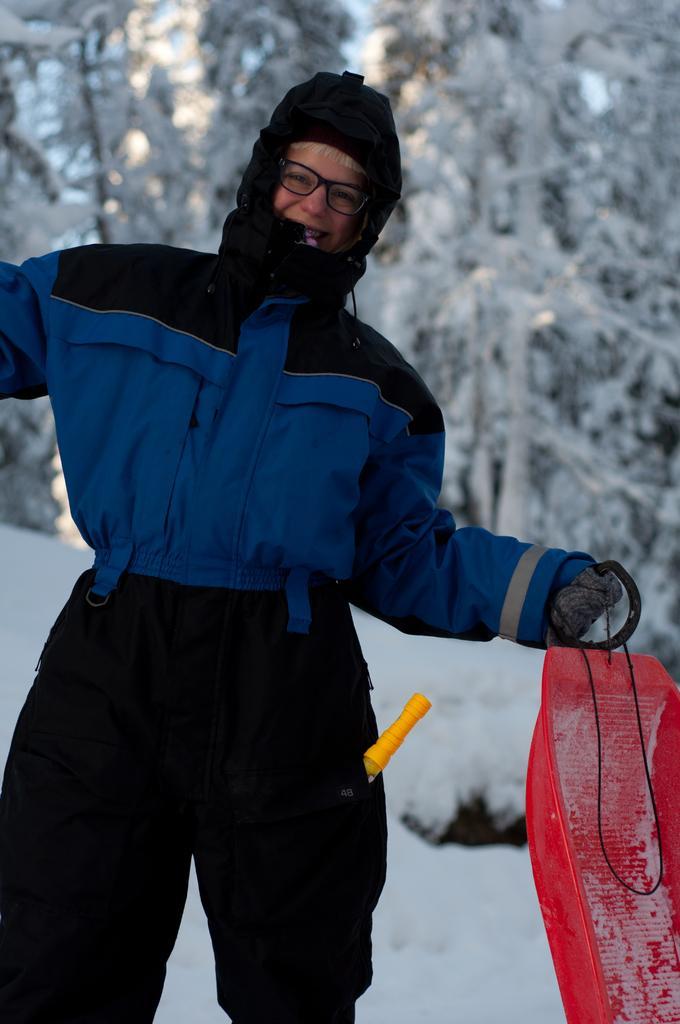In one or two sentences, can you explain what this image depicts? This picture is clicked outside. In the foreground of this picture we can see a person wearing jacket, holding some object and standing. In the background we can see there is a lot of snow and we can see the trees. 